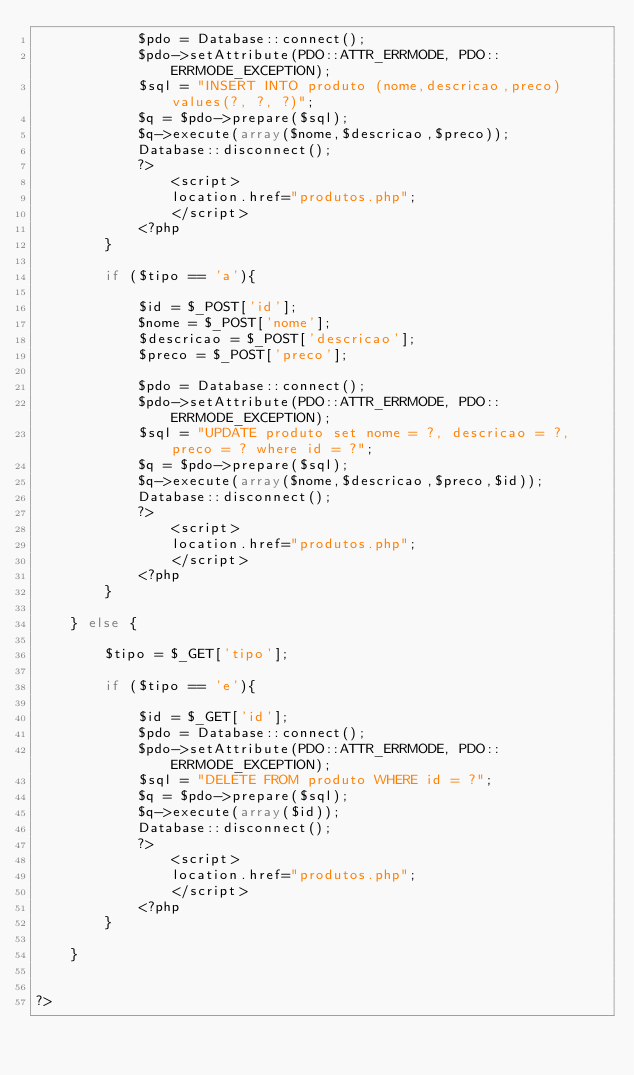<code> <loc_0><loc_0><loc_500><loc_500><_PHP_>            $pdo = Database::connect();
            $pdo->setAttribute(PDO::ATTR_ERRMODE, PDO::ERRMODE_EXCEPTION);
            $sql = "INSERT INTO produto (nome,descricao,preco) values(?, ?, ?)";
            $q = $pdo->prepare($sql);
            $q->execute(array($nome,$descricao,$preco));
            Database::disconnect();
            ?>
                <script>
                location.href="produtos.php";
                </script>
            <?php
        }

        if ($tipo == 'a'){

            $id = $_POST['id'];
            $nome = $_POST['nome'];
            $descricao = $_POST['descricao'];
            $preco = $_POST['preco'];
             
            $pdo = Database::connect();
            $pdo->setAttribute(PDO::ATTR_ERRMODE, PDO::ERRMODE_EXCEPTION);
            $sql = "UPDATE produto set nome = ?, descricao = ?, preco = ? where id = ?";
            $q = $pdo->prepare($sql);
            $q->execute(array($nome,$descricao,$preco,$id));
            Database::disconnect();
            ?>
                <script>
                location.href="produtos.php";
                </script>
            <?php
        }

    } else {

        $tipo = $_GET['tipo'];

        if ($tipo == 'e'){

            $id = $_GET['id'];
            $pdo = Database::connect();
            $pdo->setAttribute(PDO::ATTR_ERRMODE, PDO::ERRMODE_EXCEPTION);
            $sql = "DELETE FROM produto WHERE id = ?";
            $q = $pdo->prepare($sql);
            $q->execute(array($id));
            Database::disconnect();
            ?>
                <script>
                location.href="produtos.php";
                </script>
            <?php
        }

    }


?></code> 